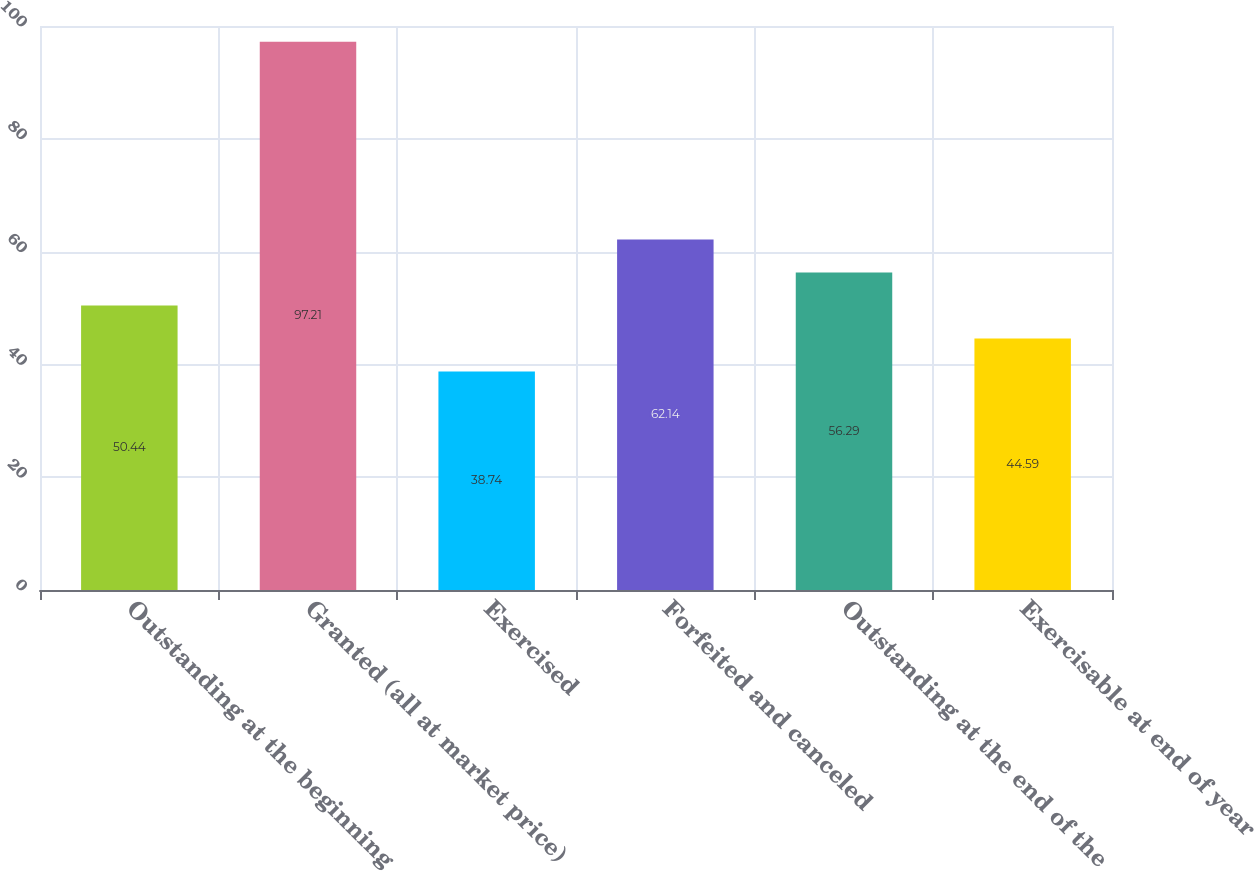<chart> <loc_0><loc_0><loc_500><loc_500><bar_chart><fcel>Outstanding at the beginning<fcel>Granted (all at market price)<fcel>Exercised<fcel>Forfeited and canceled<fcel>Outstanding at the end of the<fcel>Exercisable at end of year<nl><fcel>50.44<fcel>97.21<fcel>38.74<fcel>62.14<fcel>56.29<fcel>44.59<nl></chart> 